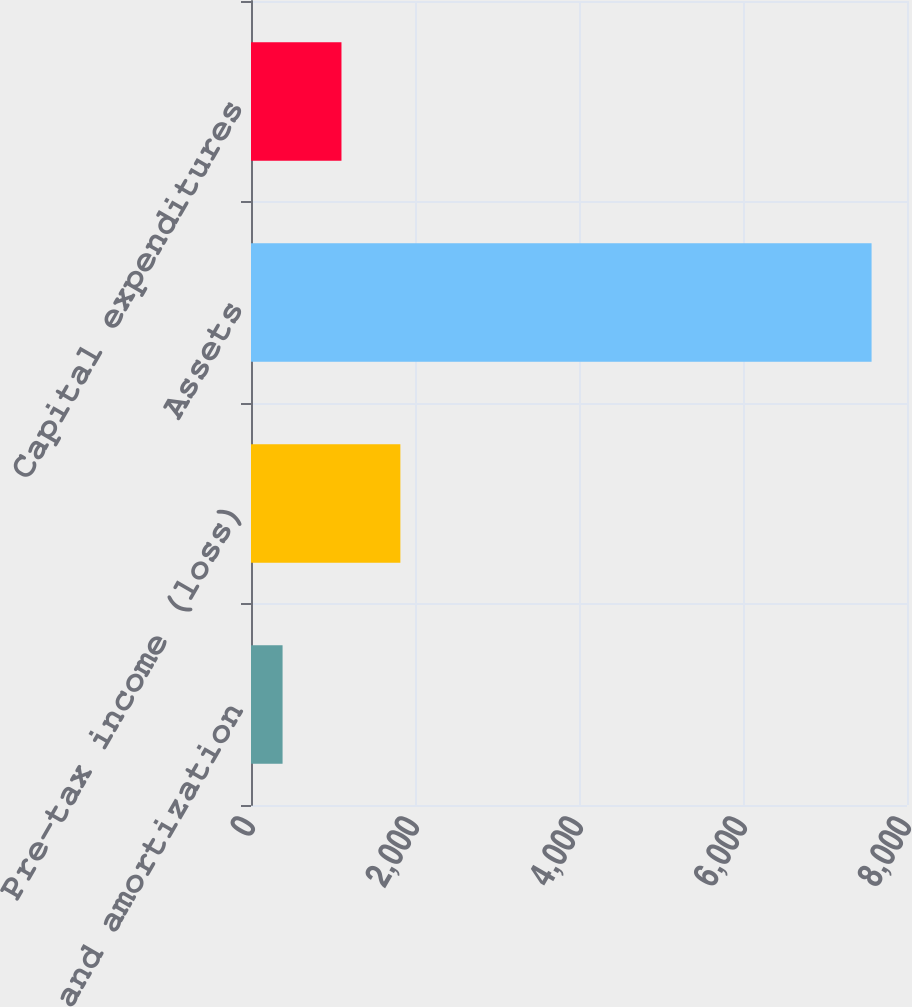Convert chart. <chart><loc_0><loc_0><loc_500><loc_500><bar_chart><fcel>Depreciation and amortization<fcel>Pre-tax income (loss)<fcel>Assets<fcel>Capital expenditures<nl><fcel>385<fcel>1821.6<fcel>7568<fcel>1103.3<nl></chart> 